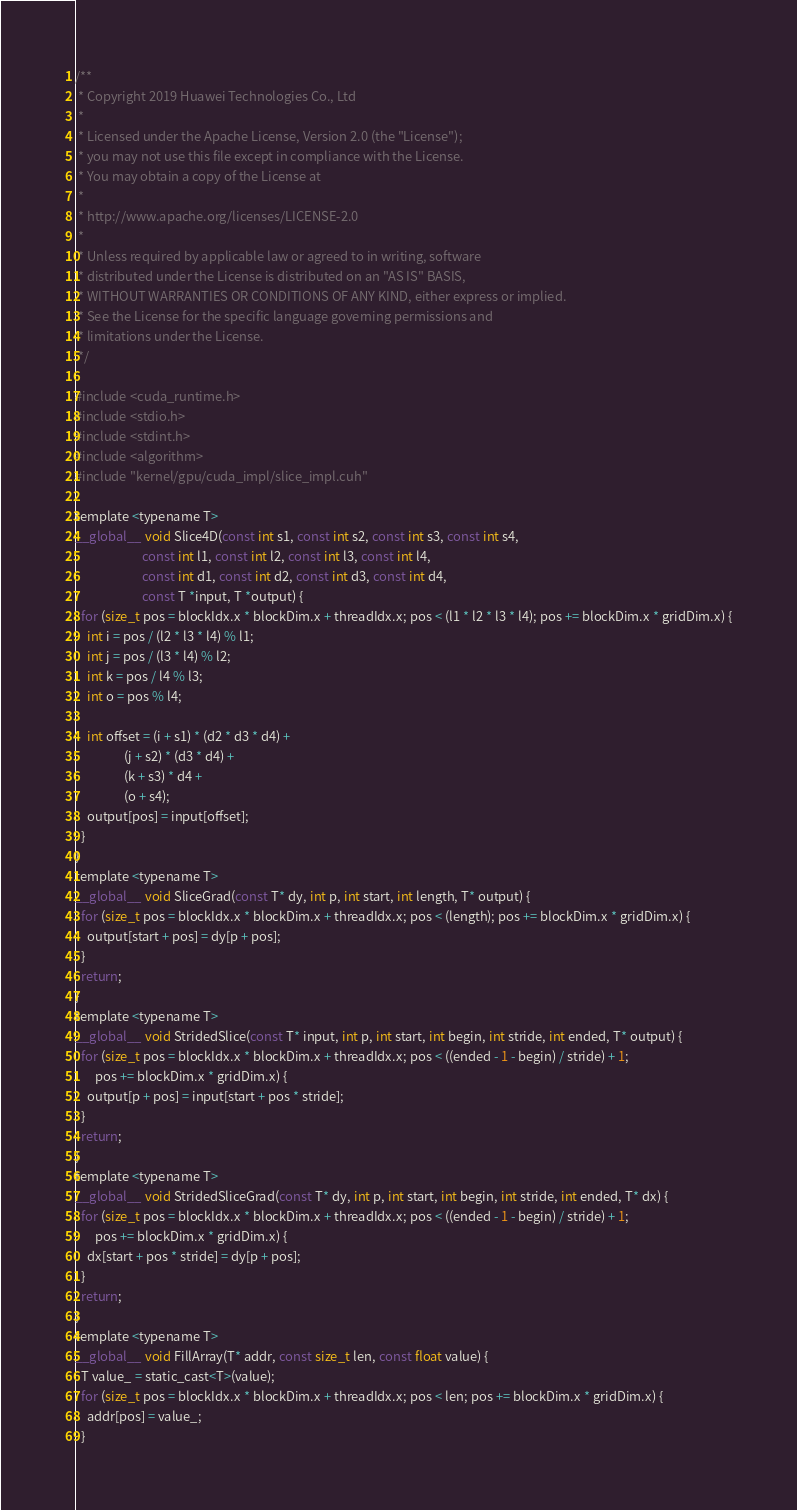Convert code to text. <code><loc_0><loc_0><loc_500><loc_500><_Cuda_>/**
 * Copyright 2019 Huawei Technologies Co., Ltd
 *
 * Licensed under the Apache License, Version 2.0 (the "License");
 * you may not use this file except in compliance with the License.
 * You may obtain a copy of the License at
 *
 * http://www.apache.org/licenses/LICENSE-2.0
 *
 * Unless required by applicable law or agreed to in writing, software
 * distributed under the License is distributed on an "AS IS" BASIS,
 * WITHOUT WARRANTIES OR CONDITIONS OF ANY KIND, either express or implied.
 * See the License for the specific language governing permissions and
 * limitations under the License.
 */

#include <cuda_runtime.h>
#include <stdio.h>
#include <stdint.h>
#include <algorithm>
#include "kernel/gpu/cuda_impl/slice_impl.cuh"

template <typename T>
__global__ void Slice4D(const int s1, const int s2, const int s3, const int s4,
                       const int l1, const int l2, const int l3, const int l4,
                       const int d1, const int d2, const int d3, const int d4,
                       const T *input, T *output) {
  for (size_t pos = blockIdx.x * blockDim.x + threadIdx.x; pos < (l1 * l2 * l3 * l4); pos += blockDim.x * gridDim.x) {
    int i = pos / (l2 * l3 * l4) % l1;
    int j = pos / (l3 * l4) % l2;
    int k = pos / l4 % l3;
    int o = pos % l4;

    int offset = (i + s1) * (d2 * d3 * d4) +
                 (j + s2) * (d3 * d4) +
                 (k + s3) * d4 +
                 (o + s4);
    output[pos] = input[offset];
  }
}
template <typename T>
__global__ void SliceGrad(const T* dy, int p, int start, int length, T* output) {
  for (size_t pos = blockIdx.x * blockDim.x + threadIdx.x; pos < (length); pos += blockDim.x * gridDim.x) {
    output[start + pos] = dy[p + pos];
  }
  return;
}
template <typename T>
__global__ void StridedSlice(const T* input, int p, int start, int begin, int stride, int ended, T* output) {
  for (size_t pos = blockIdx.x * blockDim.x + threadIdx.x; pos < ((ended - 1 - begin) / stride) + 1;
       pos += blockDim.x * gridDim.x) {
    output[p + pos] = input[start + pos * stride];
  }
  return;
}
template <typename T>
__global__ void StridedSliceGrad(const T* dy, int p, int start, int begin, int stride, int ended, T* dx) {
  for (size_t pos = blockIdx.x * blockDim.x + threadIdx.x; pos < ((ended - 1 - begin) / stride) + 1;
       pos += blockDim.x * gridDim.x) {
    dx[start + pos * stride] = dy[p + pos];
  }
  return;
}
template <typename T>
__global__ void FillArray(T* addr, const size_t len, const float value) {
  T value_ = static_cast<T>(value);
  for (size_t pos = blockIdx.x * blockDim.x + threadIdx.x; pos < len; pos += blockDim.x * gridDim.x) {
    addr[pos] = value_;
  }</code> 